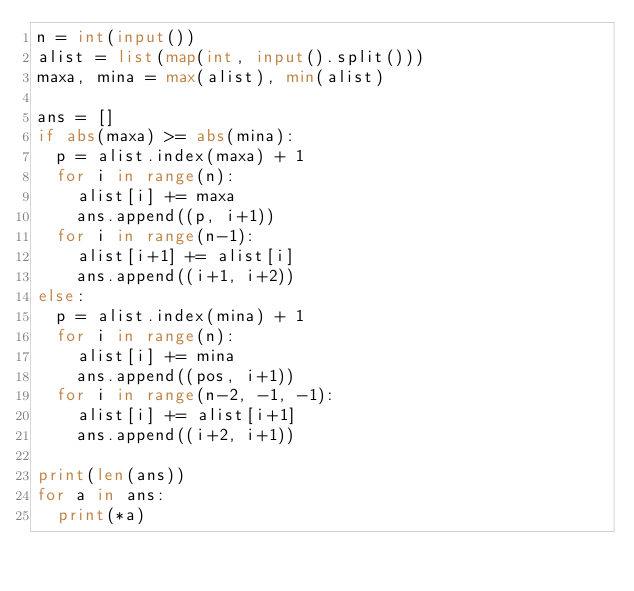Convert code to text. <code><loc_0><loc_0><loc_500><loc_500><_Python_>n = int(input())
alist = list(map(int, input().split()))
maxa, mina = max(alist), min(alist)

ans = []
if abs(maxa) >= abs(mina):
  p = alist.index(maxa) + 1
  for i in range(n):
    alist[i] += maxa
    ans.append((p, i+1))
  for i in range(n-1):
    alist[i+1] += alist[i]
    ans.append((i+1, i+2))
else:
  p = alist.index(mina) + 1
  for i in range(n):
    alist[i] += mina
    ans.append((pos, i+1))
  for i in range(n-2, -1, -1):
    alist[i] += alist[i+1]
    ans.append((i+2, i+1))

print(len(ans))
for a in ans:
  print(*a)</code> 